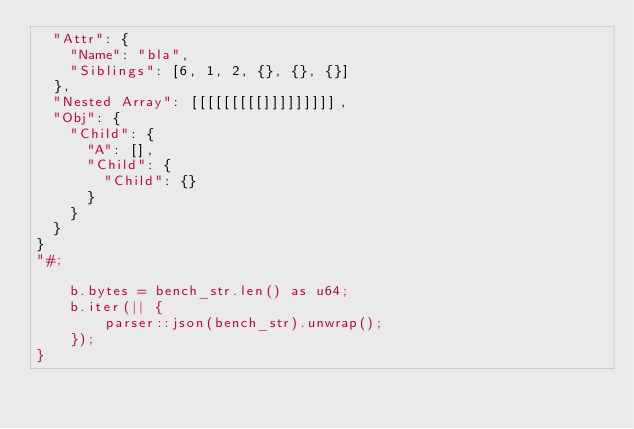Convert code to text. <code><loc_0><loc_0><loc_500><loc_500><_Rust_>	"Attr": {
		"Name": "bla",
		"Siblings": [6, 1, 2, {}, {}, {}]
	},
	"Nested Array": [[[[[[[[[]]]]]]]]],
	"Obj": {
		"Child": {
			"A": [],
			"Child": {
				"Child": {}
			}
		}
	}
}
"#;

    b.bytes = bench_str.len() as u64;
    b.iter(|| {
        parser::json(bench_str).unwrap();
    });
}
</code> 